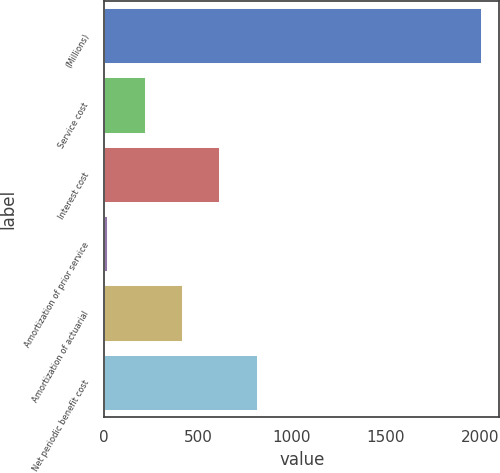Convert chart to OTSL. <chart><loc_0><loc_0><loc_500><loc_500><bar_chart><fcel>(Millions)<fcel>Service cost<fcel>Interest cost<fcel>Amortization of prior service<fcel>Amortization of actuarial<fcel>Net periodic benefit cost<nl><fcel>2003<fcel>216.5<fcel>613.5<fcel>18<fcel>415<fcel>812<nl></chart> 